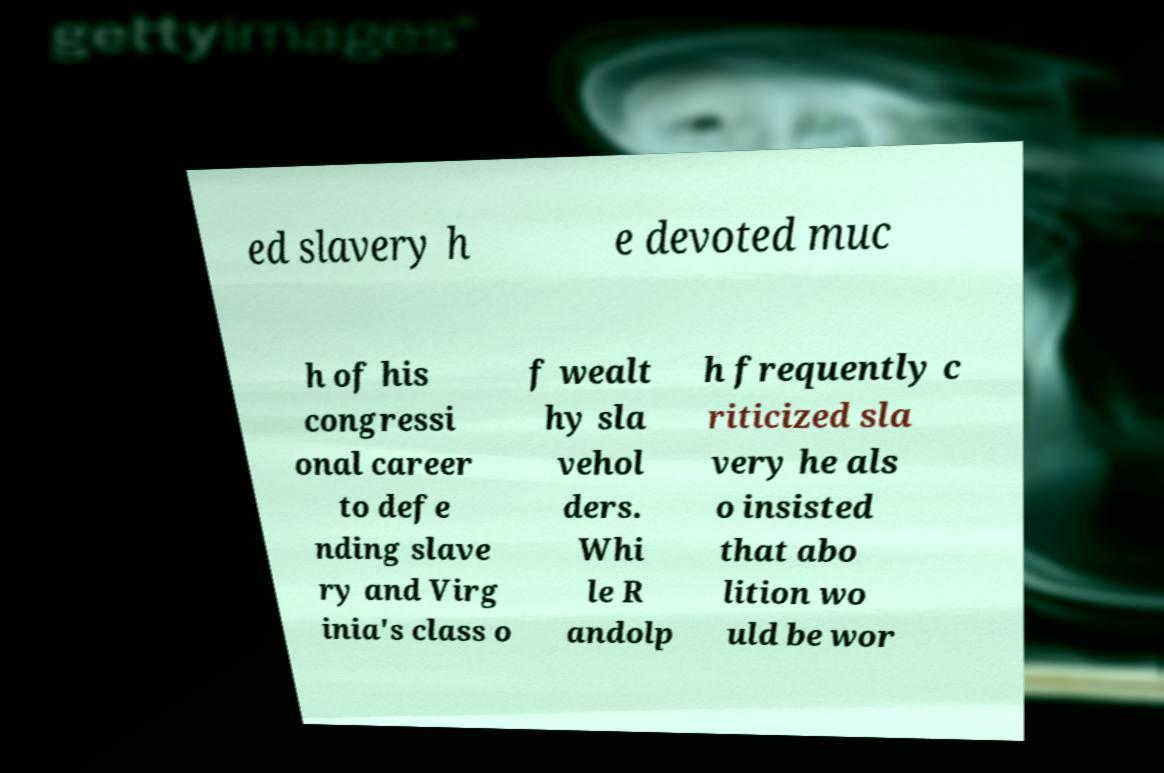I need the written content from this picture converted into text. Can you do that? ed slavery h e devoted muc h of his congressi onal career to defe nding slave ry and Virg inia's class o f wealt hy sla vehol ders. Whi le R andolp h frequently c riticized sla very he als o insisted that abo lition wo uld be wor 